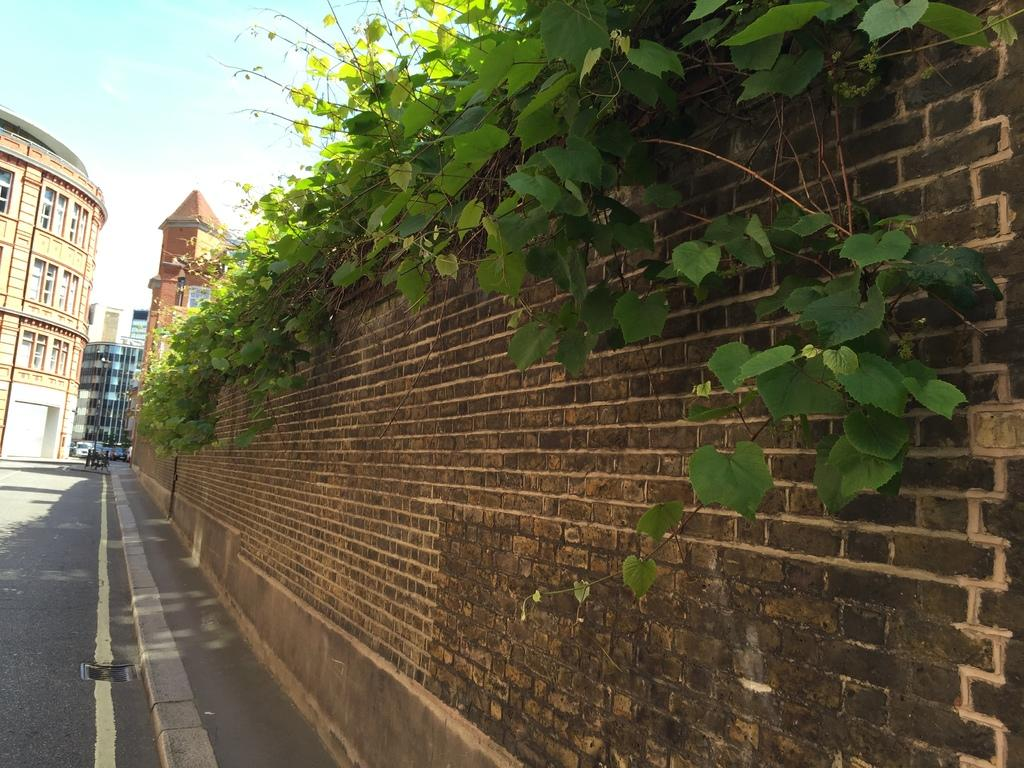What type of structure can be seen in the image? There is a wall in the image. What other elements are present in the image? There are plants, a road, and buildings visible in the image. What can be seen in the background of the image? The sky is visible in the background of the image. How many balls are hanging from the hook in the image? There is no hook or balls present in the image. 